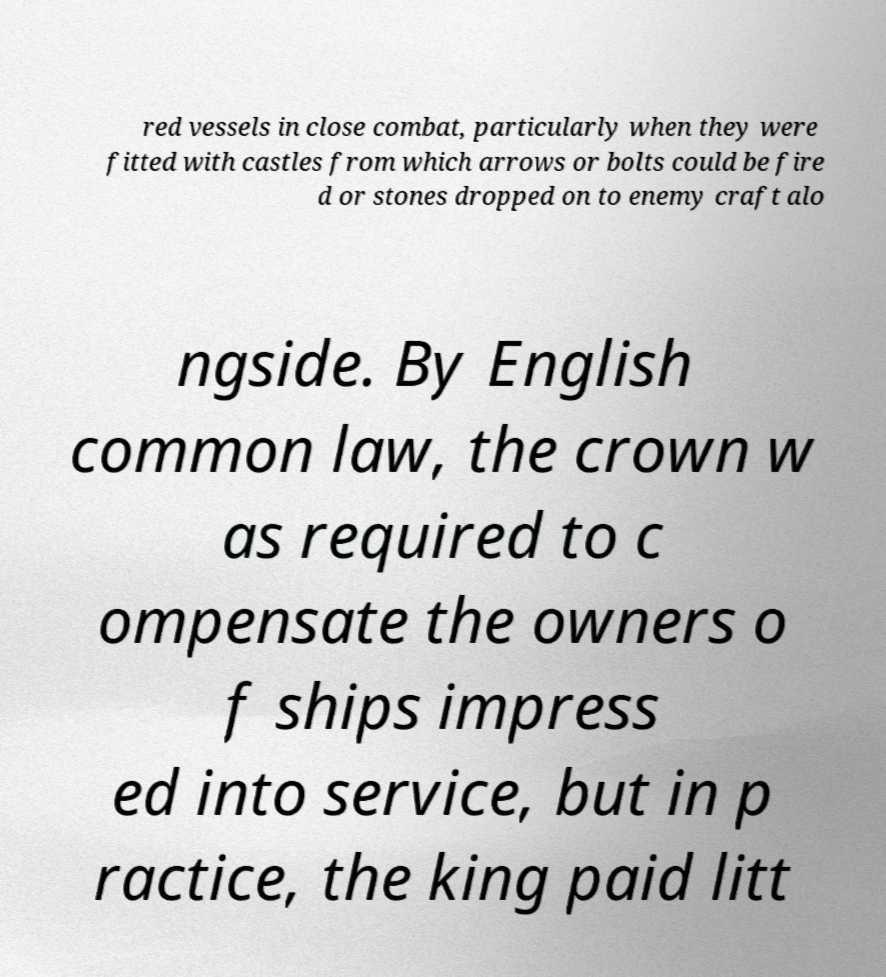Could you assist in decoding the text presented in this image and type it out clearly? red vessels in close combat, particularly when they were fitted with castles from which arrows or bolts could be fire d or stones dropped on to enemy craft alo ngside. By English common law, the crown w as required to c ompensate the owners o f ships impress ed into service, but in p ractice, the king paid litt 